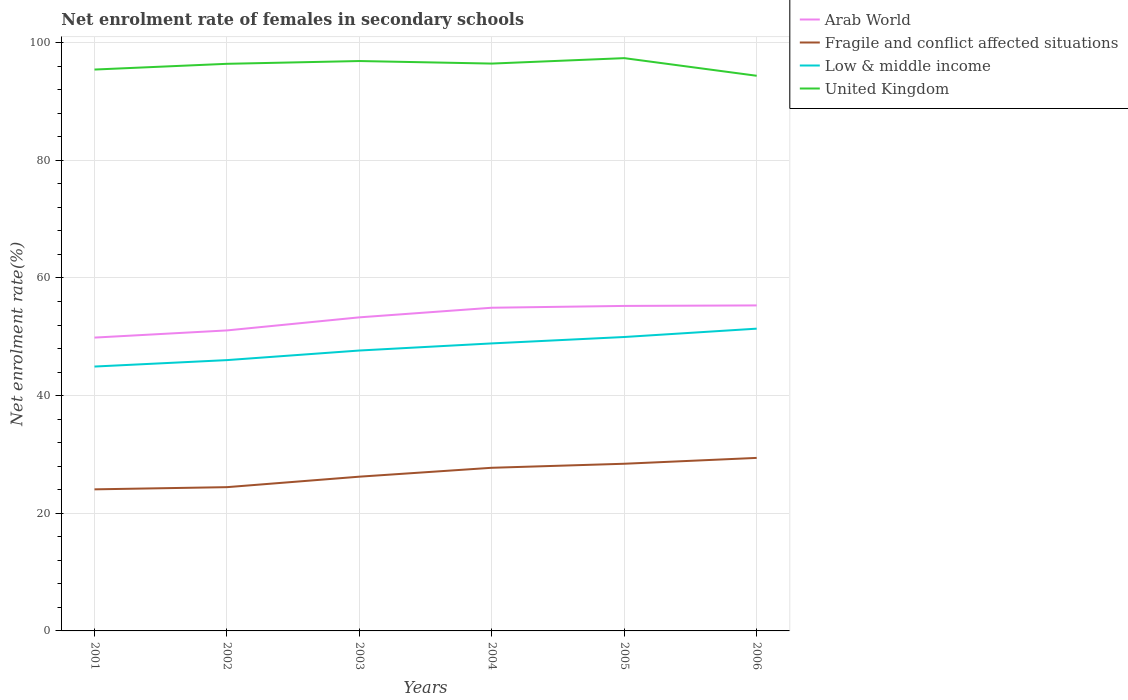How many different coloured lines are there?
Your answer should be very brief. 4. Does the line corresponding to Fragile and conflict affected situations intersect with the line corresponding to Low & middle income?
Offer a terse response. No. Is the number of lines equal to the number of legend labels?
Ensure brevity in your answer.  Yes. Across all years, what is the maximum net enrolment rate of females in secondary schools in Fragile and conflict affected situations?
Your response must be concise. 24.07. What is the total net enrolment rate of females in secondary schools in United Kingdom in the graph?
Make the answer very short. 2.51. What is the difference between the highest and the second highest net enrolment rate of females in secondary schools in Fragile and conflict affected situations?
Keep it short and to the point. 5.35. Is the net enrolment rate of females in secondary schools in Low & middle income strictly greater than the net enrolment rate of females in secondary schools in United Kingdom over the years?
Provide a succinct answer. Yes. How many lines are there?
Your answer should be compact. 4. Are the values on the major ticks of Y-axis written in scientific E-notation?
Ensure brevity in your answer.  No. Does the graph contain any zero values?
Ensure brevity in your answer.  No. Where does the legend appear in the graph?
Offer a very short reply. Top right. How are the legend labels stacked?
Your answer should be compact. Vertical. What is the title of the graph?
Provide a succinct answer. Net enrolment rate of females in secondary schools. What is the label or title of the X-axis?
Ensure brevity in your answer.  Years. What is the label or title of the Y-axis?
Give a very brief answer. Net enrolment rate(%). What is the Net enrolment rate(%) of Arab World in 2001?
Provide a succinct answer. 49.86. What is the Net enrolment rate(%) of Fragile and conflict affected situations in 2001?
Your response must be concise. 24.07. What is the Net enrolment rate(%) of Low & middle income in 2001?
Your answer should be compact. 44.94. What is the Net enrolment rate(%) in United Kingdom in 2001?
Make the answer very short. 95.43. What is the Net enrolment rate(%) in Arab World in 2002?
Provide a short and direct response. 51.08. What is the Net enrolment rate(%) of Fragile and conflict affected situations in 2002?
Provide a short and direct response. 24.44. What is the Net enrolment rate(%) in Low & middle income in 2002?
Provide a short and direct response. 46.04. What is the Net enrolment rate(%) of United Kingdom in 2002?
Make the answer very short. 96.4. What is the Net enrolment rate(%) in Arab World in 2003?
Make the answer very short. 53.31. What is the Net enrolment rate(%) in Fragile and conflict affected situations in 2003?
Keep it short and to the point. 26.22. What is the Net enrolment rate(%) of Low & middle income in 2003?
Make the answer very short. 47.67. What is the Net enrolment rate(%) of United Kingdom in 2003?
Provide a succinct answer. 96.88. What is the Net enrolment rate(%) in Arab World in 2004?
Provide a short and direct response. 54.94. What is the Net enrolment rate(%) in Fragile and conflict affected situations in 2004?
Make the answer very short. 27.73. What is the Net enrolment rate(%) of Low & middle income in 2004?
Keep it short and to the point. 48.88. What is the Net enrolment rate(%) of United Kingdom in 2004?
Keep it short and to the point. 96.44. What is the Net enrolment rate(%) of Arab World in 2005?
Provide a short and direct response. 55.25. What is the Net enrolment rate(%) in Fragile and conflict affected situations in 2005?
Keep it short and to the point. 28.42. What is the Net enrolment rate(%) in Low & middle income in 2005?
Your answer should be very brief. 49.96. What is the Net enrolment rate(%) of United Kingdom in 2005?
Ensure brevity in your answer.  97.37. What is the Net enrolment rate(%) in Arab World in 2006?
Offer a very short reply. 55.33. What is the Net enrolment rate(%) of Fragile and conflict affected situations in 2006?
Make the answer very short. 29.41. What is the Net enrolment rate(%) of Low & middle income in 2006?
Provide a short and direct response. 51.38. What is the Net enrolment rate(%) in United Kingdom in 2006?
Offer a terse response. 94.37. Across all years, what is the maximum Net enrolment rate(%) of Arab World?
Make the answer very short. 55.33. Across all years, what is the maximum Net enrolment rate(%) of Fragile and conflict affected situations?
Provide a short and direct response. 29.41. Across all years, what is the maximum Net enrolment rate(%) in Low & middle income?
Your answer should be compact. 51.38. Across all years, what is the maximum Net enrolment rate(%) in United Kingdom?
Your response must be concise. 97.37. Across all years, what is the minimum Net enrolment rate(%) of Arab World?
Your answer should be very brief. 49.86. Across all years, what is the minimum Net enrolment rate(%) in Fragile and conflict affected situations?
Keep it short and to the point. 24.07. Across all years, what is the minimum Net enrolment rate(%) of Low & middle income?
Offer a terse response. 44.94. Across all years, what is the minimum Net enrolment rate(%) of United Kingdom?
Ensure brevity in your answer.  94.37. What is the total Net enrolment rate(%) of Arab World in the graph?
Offer a very short reply. 319.77. What is the total Net enrolment rate(%) in Fragile and conflict affected situations in the graph?
Offer a very short reply. 160.29. What is the total Net enrolment rate(%) in Low & middle income in the graph?
Provide a succinct answer. 288.87. What is the total Net enrolment rate(%) of United Kingdom in the graph?
Give a very brief answer. 576.9. What is the difference between the Net enrolment rate(%) in Arab World in 2001 and that in 2002?
Give a very brief answer. -1.22. What is the difference between the Net enrolment rate(%) of Fragile and conflict affected situations in 2001 and that in 2002?
Your response must be concise. -0.37. What is the difference between the Net enrolment rate(%) in Low & middle income in 2001 and that in 2002?
Make the answer very short. -1.09. What is the difference between the Net enrolment rate(%) of United Kingdom in 2001 and that in 2002?
Your answer should be very brief. -0.97. What is the difference between the Net enrolment rate(%) of Arab World in 2001 and that in 2003?
Keep it short and to the point. -3.44. What is the difference between the Net enrolment rate(%) in Fragile and conflict affected situations in 2001 and that in 2003?
Offer a terse response. -2.15. What is the difference between the Net enrolment rate(%) in Low & middle income in 2001 and that in 2003?
Make the answer very short. -2.72. What is the difference between the Net enrolment rate(%) in United Kingdom in 2001 and that in 2003?
Provide a succinct answer. -1.45. What is the difference between the Net enrolment rate(%) of Arab World in 2001 and that in 2004?
Your response must be concise. -5.08. What is the difference between the Net enrolment rate(%) in Fragile and conflict affected situations in 2001 and that in 2004?
Your answer should be very brief. -3.67. What is the difference between the Net enrolment rate(%) of Low & middle income in 2001 and that in 2004?
Provide a short and direct response. -3.93. What is the difference between the Net enrolment rate(%) of United Kingdom in 2001 and that in 2004?
Keep it short and to the point. -1.01. What is the difference between the Net enrolment rate(%) of Arab World in 2001 and that in 2005?
Give a very brief answer. -5.38. What is the difference between the Net enrolment rate(%) in Fragile and conflict affected situations in 2001 and that in 2005?
Your answer should be very brief. -4.35. What is the difference between the Net enrolment rate(%) in Low & middle income in 2001 and that in 2005?
Keep it short and to the point. -5.02. What is the difference between the Net enrolment rate(%) in United Kingdom in 2001 and that in 2005?
Keep it short and to the point. -1.94. What is the difference between the Net enrolment rate(%) in Arab World in 2001 and that in 2006?
Keep it short and to the point. -5.47. What is the difference between the Net enrolment rate(%) of Fragile and conflict affected situations in 2001 and that in 2006?
Give a very brief answer. -5.35. What is the difference between the Net enrolment rate(%) in Low & middle income in 2001 and that in 2006?
Offer a terse response. -6.44. What is the difference between the Net enrolment rate(%) of United Kingdom in 2001 and that in 2006?
Provide a short and direct response. 1.06. What is the difference between the Net enrolment rate(%) in Arab World in 2002 and that in 2003?
Your answer should be very brief. -2.22. What is the difference between the Net enrolment rate(%) in Fragile and conflict affected situations in 2002 and that in 2003?
Keep it short and to the point. -1.78. What is the difference between the Net enrolment rate(%) of Low & middle income in 2002 and that in 2003?
Make the answer very short. -1.63. What is the difference between the Net enrolment rate(%) of United Kingdom in 2002 and that in 2003?
Keep it short and to the point. -0.47. What is the difference between the Net enrolment rate(%) of Arab World in 2002 and that in 2004?
Ensure brevity in your answer.  -3.86. What is the difference between the Net enrolment rate(%) of Fragile and conflict affected situations in 2002 and that in 2004?
Your answer should be compact. -3.3. What is the difference between the Net enrolment rate(%) in Low & middle income in 2002 and that in 2004?
Give a very brief answer. -2.84. What is the difference between the Net enrolment rate(%) of United Kingdom in 2002 and that in 2004?
Your response must be concise. -0.04. What is the difference between the Net enrolment rate(%) of Arab World in 2002 and that in 2005?
Offer a very short reply. -4.16. What is the difference between the Net enrolment rate(%) of Fragile and conflict affected situations in 2002 and that in 2005?
Your answer should be compact. -3.98. What is the difference between the Net enrolment rate(%) in Low & middle income in 2002 and that in 2005?
Your answer should be very brief. -3.93. What is the difference between the Net enrolment rate(%) in United Kingdom in 2002 and that in 2005?
Your answer should be compact. -0.97. What is the difference between the Net enrolment rate(%) in Arab World in 2002 and that in 2006?
Your response must be concise. -4.25. What is the difference between the Net enrolment rate(%) of Fragile and conflict affected situations in 2002 and that in 2006?
Make the answer very short. -4.97. What is the difference between the Net enrolment rate(%) in Low & middle income in 2002 and that in 2006?
Ensure brevity in your answer.  -5.35. What is the difference between the Net enrolment rate(%) in United Kingdom in 2002 and that in 2006?
Provide a succinct answer. 2.03. What is the difference between the Net enrolment rate(%) in Arab World in 2003 and that in 2004?
Your response must be concise. -1.63. What is the difference between the Net enrolment rate(%) of Fragile and conflict affected situations in 2003 and that in 2004?
Provide a short and direct response. -1.51. What is the difference between the Net enrolment rate(%) of Low & middle income in 2003 and that in 2004?
Your answer should be compact. -1.21. What is the difference between the Net enrolment rate(%) in United Kingdom in 2003 and that in 2004?
Provide a succinct answer. 0.43. What is the difference between the Net enrolment rate(%) in Arab World in 2003 and that in 2005?
Provide a short and direct response. -1.94. What is the difference between the Net enrolment rate(%) of Fragile and conflict affected situations in 2003 and that in 2005?
Keep it short and to the point. -2.2. What is the difference between the Net enrolment rate(%) in Low & middle income in 2003 and that in 2005?
Provide a succinct answer. -2.3. What is the difference between the Net enrolment rate(%) of United Kingdom in 2003 and that in 2005?
Give a very brief answer. -0.49. What is the difference between the Net enrolment rate(%) of Arab World in 2003 and that in 2006?
Your answer should be compact. -2.03. What is the difference between the Net enrolment rate(%) of Fragile and conflict affected situations in 2003 and that in 2006?
Provide a succinct answer. -3.19. What is the difference between the Net enrolment rate(%) of Low & middle income in 2003 and that in 2006?
Your answer should be very brief. -3.72. What is the difference between the Net enrolment rate(%) in United Kingdom in 2003 and that in 2006?
Your response must be concise. 2.51. What is the difference between the Net enrolment rate(%) in Arab World in 2004 and that in 2005?
Offer a terse response. -0.31. What is the difference between the Net enrolment rate(%) of Fragile and conflict affected situations in 2004 and that in 2005?
Ensure brevity in your answer.  -0.68. What is the difference between the Net enrolment rate(%) in Low & middle income in 2004 and that in 2005?
Keep it short and to the point. -1.09. What is the difference between the Net enrolment rate(%) in United Kingdom in 2004 and that in 2005?
Ensure brevity in your answer.  -0.93. What is the difference between the Net enrolment rate(%) of Arab World in 2004 and that in 2006?
Your answer should be compact. -0.39. What is the difference between the Net enrolment rate(%) in Fragile and conflict affected situations in 2004 and that in 2006?
Your response must be concise. -1.68. What is the difference between the Net enrolment rate(%) in Low & middle income in 2004 and that in 2006?
Keep it short and to the point. -2.51. What is the difference between the Net enrolment rate(%) in United Kingdom in 2004 and that in 2006?
Provide a short and direct response. 2.07. What is the difference between the Net enrolment rate(%) in Arab World in 2005 and that in 2006?
Ensure brevity in your answer.  -0.09. What is the difference between the Net enrolment rate(%) in Fragile and conflict affected situations in 2005 and that in 2006?
Give a very brief answer. -0.99. What is the difference between the Net enrolment rate(%) in Low & middle income in 2005 and that in 2006?
Your answer should be very brief. -1.42. What is the difference between the Net enrolment rate(%) in United Kingdom in 2005 and that in 2006?
Make the answer very short. 3. What is the difference between the Net enrolment rate(%) of Arab World in 2001 and the Net enrolment rate(%) of Fragile and conflict affected situations in 2002?
Ensure brevity in your answer.  25.43. What is the difference between the Net enrolment rate(%) of Arab World in 2001 and the Net enrolment rate(%) of Low & middle income in 2002?
Ensure brevity in your answer.  3.83. What is the difference between the Net enrolment rate(%) in Arab World in 2001 and the Net enrolment rate(%) in United Kingdom in 2002?
Ensure brevity in your answer.  -46.54. What is the difference between the Net enrolment rate(%) in Fragile and conflict affected situations in 2001 and the Net enrolment rate(%) in Low & middle income in 2002?
Your answer should be very brief. -21.97. What is the difference between the Net enrolment rate(%) of Fragile and conflict affected situations in 2001 and the Net enrolment rate(%) of United Kingdom in 2002?
Make the answer very short. -72.34. What is the difference between the Net enrolment rate(%) in Low & middle income in 2001 and the Net enrolment rate(%) in United Kingdom in 2002?
Provide a short and direct response. -51.46. What is the difference between the Net enrolment rate(%) in Arab World in 2001 and the Net enrolment rate(%) in Fragile and conflict affected situations in 2003?
Your response must be concise. 23.64. What is the difference between the Net enrolment rate(%) in Arab World in 2001 and the Net enrolment rate(%) in Low & middle income in 2003?
Provide a succinct answer. 2.2. What is the difference between the Net enrolment rate(%) of Arab World in 2001 and the Net enrolment rate(%) of United Kingdom in 2003?
Your answer should be very brief. -47.01. What is the difference between the Net enrolment rate(%) in Fragile and conflict affected situations in 2001 and the Net enrolment rate(%) in Low & middle income in 2003?
Offer a terse response. -23.6. What is the difference between the Net enrolment rate(%) in Fragile and conflict affected situations in 2001 and the Net enrolment rate(%) in United Kingdom in 2003?
Offer a terse response. -72.81. What is the difference between the Net enrolment rate(%) of Low & middle income in 2001 and the Net enrolment rate(%) of United Kingdom in 2003?
Your answer should be very brief. -51.93. What is the difference between the Net enrolment rate(%) of Arab World in 2001 and the Net enrolment rate(%) of Fragile and conflict affected situations in 2004?
Your answer should be very brief. 22.13. What is the difference between the Net enrolment rate(%) of Arab World in 2001 and the Net enrolment rate(%) of United Kingdom in 2004?
Offer a very short reply. -46.58. What is the difference between the Net enrolment rate(%) in Fragile and conflict affected situations in 2001 and the Net enrolment rate(%) in Low & middle income in 2004?
Offer a very short reply. -24.81. What is the difference between the Net enrolment rate(%) of Fragile and conflict affected situations in 2001 and the Net enrolment rate(%) of United Kingdom in 2004?
Give a very brief answer. -72.38. What is the difference between the Net enrolment rate(%) of Low & middle income in 2001 and the Net enrolment rate(%) of United Kingdom in 2004?
Your response must be concise. -51.5. What is the difference between the Net enrolment rate(%) in Arab World in 2001 and the Net enrolment rate(%) in Fragile and conflict affected situations in 2005?
Provide a succinct answer. 21.45. What is the difference between the Net enrolment rate(%) of Arab World in 2001 and the Net enrolment rate(%) of Low & middle income in 2005?
Your answer should be very brief. -0.1. What is the difference between the Net enrolment rate(%) of Arab World in 2001 and the Net enrolment rate(%) of United Kingdom in 2005?
Your answer should be compact. -47.51. What is the difference between the Net enrolment rate(%) in Fragile and conflict affected situations in 2001 and the Net enrolment rate(%) in Low & middle income in 2005?
Make the answer very short. -25.9. What is the difference between the Net enrolment rate(%) of Fragile and conflict affected situations in 2001 and the Net enrolment rate(%) of United Kingdom in 2005?
Your answer should be compact. -73.3. What is the difference between the Net enrolment rate(%) of Low & middle income in 2001 and the Net enrolment rate(%) of United Kingdom in 2005?
Your response must be concise. -52.43. What is the difference between the Net enrolment rate(%) in Arab World in 2001 and the Net enrolment rate(%) in Fragile and conflict affected situations in 2006?
Ensure brevity in your answer.  20.45. What is the difference between the Net enrolment rate(%) in Arab World in 2001 and the Net enrolment rate(%) in Low & middle income in 2006?
Offer a very short reply. -1.52. What is the difference between the Net enrolment rate(%) of Arab World in 2001 and the Net enrolment rate(%) of United Kingdom in 2006?
Provide a short and direct response. -44.51. What is the difference between the Net enrolment rate(%) of Fragile and conflict affected situations in 2001 and the Net enrolment rate(%) of Low & middle income in 2006?
Offer a very short reply. -27.32. What is the difference between the Net enrolment rate(%) of Fragile and conflict affected situations in 2001 and the Net enrolment rate(%) of United Kingdom in 2006?
Give a very brief answer. -70.3. What is the difference between the Net enrolment rate(%) in Low & middle income in 2001 and the Net enrolment rate(%) in United Kingdom in 2006?
Provide a short and direct response. -49.43. What is the difference between the Net enrolment rate(%) of Arab World in 2002 and the Net enrolment rate(%) of Fragile and conflict affected situations in 2003?
Offer a terse response. 24.86. What is the difference between the Net enrolment rate(%) in Arab World in 2002 and the Net enrolment rate(%) in Low & middle income in 2003?
Your answer should be very brief. 3.42. What is the difference between the Net enrolment rate(%) of Arab World in 2002 and the Net enrolment rate(%) of United Kingdom in 2003?
Provide a succinct answer. -45.79. What is the difference between the Net enrolment rate(%) in Fragile and conflict affected situations in 2002 and the Net enrolment rate(%) in Low & middle income in 2003?
Ensure brevity in your answer.  -23.23. What is the difference between the Net enrolment rate(%) of Fragile and conflict affected situations in 2002 and the Net enrolment rate(%) of United Kingdom in 2003?
Keep it short and to the point. -72.44. What is the difference between the Net enrolment rate(%) in Low & middle income in 2002 and the Net enrolment rate(%) in United Kingdom in 2003?
Your answer should be compact. -50.84. What is the difference between the Net enrolment rate(%) of Arab World in 2002 and the Net enrolment rate(%) of Fragile and conflict affected situations in 2004?
Provide a succinct answer. 23.35. What is the difference between the Net enrolment rate(%) in Arab World in 2002 and the Net enrolment rate(%) in Low & middle income in 2004?
Your response must be concise. 2.21. What is the difference between the Net enrolment rate(%) of Arab World in 2002 and the Net enrolment rate(%) of United Kingdom in 2004?
Offer a very short reply. -45.36. What is the difference between the Net enrolment rate(%) in Fragile and conflict affected situations in 2002 and the Net enrolment rate(%) in Low & middle income in 2004?
Your response must be concise. -24.44. What is the difference between the Net enrolment rate(%) in Fragile and conflict affected situations in 2002 and the Net enrolment rate(%) in United Kingdom in 2004?
Provide a succinct answer. -72.01. What is the difference between the Net enrolment rate(%) in Low & middle income in 2002 and the Net enrolment rate(%) in United Kingdom in 2004?
Ensure brevity in your answer.  -50.41. What is the difference between the Net enrolment rate(%) in Arab World in 2002 and the Net enrolment rate(%) in Fragile and conflict affected situations in 2005?
Offer a very short reply. 22.67. What is the difference between the Net enrolment rate(%) in Arab World in 2002 and the Net enrolment rate(%) in Low & middle income in 2005?
Provide a short and direct response. 1.12. What is the difference between the Net enrolment rate(%) in Arab World in 2002 and the Net enrolment rate(%) in United Kingdom in 2005?
Make the answer very short. -46.29. What is the difference between the Net enrolment rate(%) of Fragile and conflict affected situations in 2002 and the Net enrolment rate(%) of Low & middle income in 2005?
Your response must be concise. -25.53. What is the difference between the Net enrolment rate(%) in Fragile and conflict affected situations in 2002 and the Net enrolment rate(%) in United Kingdom in 2005?
Give a very brief answer. -72.93. What is the difference between the Net enrolment rate(%) of Low & middle income in 2002 and the Net enrolment rate(%) of United Kingdom in 2005?
Your response must be concise. -51.33. What is the difference between the Net enrolment rate(%) of Arab World in 2002 and the Net enrolment rate(%) of Fragile and conflict affected situations in 2006?
Offer a terse response. 21.67. What is the difference between the Net enrolment rate(%) in Arab World in 2002 and the Net enrolment rate(%) in Low & middle income in 2006?
Offer a very short reply. -0.3. What is the difference between the Net enrolment rate(%) in Arab World in 2002 and the Net enrolment rate(%) in United Kingdom in 2006?
Your response must be concise. -43.29. What is the difference between the Net enrolment rate(%) of Fragile and conflict affected situations in 2002 and the Net enrolment rate(%) of Low & middle income in 2006?
Make the answer very short. -26.94. What is the difference between the Net enrolment rate(%) of Fragile and conflict affected situations in 2002 and the Net enrolment rate(%) of United Kingdom in 2006?
Your response must be concise. -69.93. What is the difference between the Net enrolment rate(%) of Low & middle income in 2002 and the Net enrolment rate(%) of United Kingdom in 2006?
Offer a very short reply. -48.34. What is the difference between the Net enrolment rate(%) of Arab World in 2003 and the Net enrolment rate(%) of Fragile and conflict affected situations in 2004?
Provide a succinct answer. 25.57. What is the difference between the Net enrolment rate(%) in Arab World in 2003 and the Net enrolment rate(%) in Low & middle income in 2004?
Provide a short and direct response. 4.43. What is the difference between the Net enrolment rate(%) of Arab World in 2003 and the Net enrolment rate(%) of United Kingdom in 2004?
Offer a very short reply. -43.14. What is the difference between the Net enrolment rate(%) of Fragile and conflict affected situations in 2003 and the Net enrolment rate(%) of Low & middle income in 2004?
Provide a succinct answer. -22.66. What is the difference between the Net enrolment rate(%) of Fragile and conflict affected situations in 2003 and the Net enrolment rate(%) of United Kingdom in 2004?
Provide a short and direct response. -70.22. What is the difference between the Net enrolment rate(%) of Low & middle income in 2003 and the Net enrolment rate(%) of United Kingdom in 2004?
Offer a terse response. -48.78. What is the difference between the Net enrolment rate(%) in Arab World in 2003 and the Net enrolment rate(%) in Fragile and conflict affected situations in 2005?
Offer a very short reply. 24.89. What is the difference between the Net enrolment rate(%) in Arab World in 2003 and the Net enrolment rate(%) in Low & middle income in 2005?
Provide a short and direct response. 3.34. What is the difference between the Net enrolment rate(%) of Arab World in 2003 and the Net enrolment rate(%) of United Kingdom in 2005?
Your answer should be very brief. -44.06. What is the difference between the Net enrolment rate(%) of Fragile and conflict affected situations in 2003 and the Net enrolment rate(%) of Low & middle income in 2005?
Provide a short and direct response. -23.74. What is the difference between the Net enrolment rate(%) of Fragile and conflict affected situations in 2003 and the Net enrolment rate(%) of United Kingdom in 2005?
Your answer should be compact. -71.15. What is the difference between the Net enrolment rate(%) in Low & middle income in 2003 and the Net enrolment rate(%) in United Kingdom in 2005?
Provide a succinct answer. -49.7. What is the difference between the Net enrolment rate(%) of Arab World in 2003 and the Net enrolment rate(%) of Fragile and conflict affected situations in 2006?
Your answer should be compact. 23.89. What is the difference between the Net enrolment rate(%) of Arab World in 2003 and the Net enrolment rate(%) of Low & middle income in 2006?
Ensure brevity in your answer.  1.92. What is the difference between the Net enrolment rate(%) of Arab World in 2003 and the Net enrolment rate(%) of United Kingdom in 2006?
Make the answer very short. -41.07. What is the difference between the Net enrolment rate(%) in Fragile and conflict affected situations in 2003 and the Net enrolment rate(%) in Low & middle income in 2006?
Offer a terse response. -25.16. What is the difference between the Net enrolment rate(%) in Fragile and conflict affected situations in 2003 and the Net enrolment rate(%) in United Kingdom in 2006?
Provide a short and direct response. -68.15. What is the difference between the Net enrolment rate(%) of Low & middle income in 2003 and the Net enrolment rate(%) of United Kingdom in 2006?
Provide a succinct answer. -46.71. What is the difference between the Net enrolment rate(%) of Arab World in 2004 and the Net enrolment rate(%) of Fragile and conflict affected situations in 2005?
Give a very brief answer. 26.52. What is the difference between the Net enrolment rate(%) in Arab World in 2004 and the Net enrolment rate(%) in Low & middle income in 2005?
Your answer should be compact. 4.97. What is the difference between the Net enrolment rate(%) in Arab World in 2004 and the Net enrolment rate(%) in United Kingdom in 2005?
Your answer should be compact. -42.43. What is the difference between the Net enrolment rate(%) of Fragile and conflict affected situations in 2004 and the Net enrolment rate(%) of Low & middle income in 2005?
Your response must be concise. -22.23. What is the difference between the Net enrolment rate(%) in Fragile and conflict affected situations in 2004 and the Net enrolment rate(%) in United Kingdom in 2005?
Provide a short and direct response. -69.64. What is the difference between the Net enrolment rate(%) of Low & middle income in 2004 and the Net enrolment rate(%) of United Kingdom in 2005?
Offer a terse response. -48.49. What is the difference between the Net enrolment rate(%) of Arab World in 2004 and the Net enrolment rate(%) of Fragile and conflict affected situations in 2006?
Provide a short and direct response. 25.53. What is the difference between the Net enrolment rate(%) in Arab World in 2004 and the Net enrolment rate(%) in Low & middle income in 2006?
Your response must be concise. 3.56. What is the difference between the Net enrolment rate(%) in Arab World in 2004 and the Net enrolment rate(%) in United Kingdom in 2006?
Your response must be concise. -39.43. What is the difference between the Net enrolment rate(%) in Fragile and conflict affected situations in 2004 and the Net enrolment rate(%) in Low & middle income in 2006?
Keep it short and to the point. -23.65. What is the difference between the Net enrolment rate(%) of Fragile and conflict affected situations in 2004 and the Net enrolment rate(%) of United Kingdom in 2006?
Your answer should be very brief. -66.64. What is the difference between the Net enrolment rate(%) in Low & middle income in 2004 and the Net enrolment rate(%) in United Kingdom in 2006?
Keep it short and to the point. -45.5. What is the difference between the Net enrolment rate(%) in Arab World in 2005 and the Net enrolment rate(%) in Fragile and conflict affected situations in 2006?
Your answer should be very brief. 25.83. What is the difference between the Net enrolment rate(%) in Arab World in 2005 and the Net enrolment rate(%) in Low & middle income in 2006?
Provide a succinct answer. 3.86. What is the difference between the Net enrolment rate(%) of Arab World in 2005 and the Net enrolment rate(%) of United Kingdom in 2006?
Keep it short and to the point. -39.13. What is the difference between the Net enrolment rate(%) in Fragile and conflict affected situations in 2005 and the Net enrolment rate(%) in Low & middle income in 2006?
Your response must be concise. -22.96. What is the difference between the Net enrolment rate(%) of Fragile and conflict affected situations in 2005 and the Net enrolment rate(%) of United Kingdom in 2006?
Offer a very short reply. -65.95. What is the difference between the Net enrolment rate(%) of Low & middle income in 2005 and the Net enrolment rate(%) of United Kingdom in 2006?
Keep it short and to the point. -44.41. What is the average Net enrolment rate(%) of Arab World per year?
Provide a succinct answer. 53.3. What is the average Net enrolment rate(%) of Fragile and conflict affected situations per year?
Give a very brief answer. 26.72. What is the average Net enrolment rate(%) of Low & middle income per year?
Offer a terse response. 48.14. What is the average Net enrolment rate(%) in United Kingdom per year?
Ensure brevity in your answer.  96.15. In the year 2001, what is the difference between the Net enrolment rate(%) of Arab World and Net enrolment rate(%) of Fragile and conflict affected situations?
Provide a short and direct response. 25.8. In the year 2001, what is the difference between the Net enrolment rate(%) of Arab World and Net enrolment rate(%) of Low & middle income?
Your answer should be compact. 4.92. In the year 2001, what is the difference between the Net enrolment rate(%) in Arab World and Net enrolment rate(%) in United Kingdom?
Offer a very short reply. -45.57. In the year 2001, what is the difference between the Net enrolment rate(%) of Fragile and conflict affected situations and Net enrolment rate(%) of Low & middle income?
Ensure brevity in your answer.  -20.88. In the year 2001, what is the difference between the Net enrolment rate(%) of Fragile and conflict affected situations and Net enrolment rate(%) of United Kingdom?
Your answer should be compact. -71.36. In the year 2001, what is the difference between the Net enrolment rate(%) of Low & middle income and Net enrolment rate(%) of United Kingdom?
Your response must be concise. -50.49. In the year 2002, what is the difference between the Net enrolment rate(%) of Arab World and Net enrolment rate(%) of Fragile and conflict affected situations?
Offer a very short reply. 26.65. In the year 2002, what is the difference between the Net enrolment rate(%) of Arab World and Net enrolment rate(%) of Low & middle income?
Keep it short and to the point. 5.05. In the year 2002, what is the difference between the Net enrolment rate(%) of Arab World and Net enrolment rate(%) of United Kingdom?
Your response must be concise. -45.32. In the year 2002, what is the difference between the Net enrolment rate(%) of Fragile and conflict affected situations and Net enrolment rate(%) of Low & middle income?
Provide a succinct answer. -21.6. In the year 2002, what is the difference between the Net enrolment rate(%) in Fragile and conflict affected situations and Net enrolment rate(%) in United Kingdom?
Your response must be concise. -71.97. In the year 2002, what is the difference between the Net enrolment rate(%) of Low & middle income and Net enrolment rate(%) of United Kingdom?
Provide a short and direct response. -50.37. In the year 2003, what is the difference between the Net enrolment rate(%) in Arab World and Net enrolment rate(%) in Fragile and conflict affected situations?
Offer a terse response. 27.08. In the year 2003, what is the difference between the Net enrolment rate(%) in Arab World and Net enrolment rate(%) in Low & middle income?
Offer a terse response. 5.64. In the year 2003, what is the difference between the Net enrolment rate(%) of Arab World and Net enrolment rate(%) of United Kingdom?
Give a very brief answer. -43.57. In the year 2003, what is the difference between the Net enrolment rate(%) in Fragile and conflict affected situations and Net enrolment rate(%) in Low & middle income?
Provide a succinct answer. -21.45. In the year 2003, what is the difference between the Net enrolment rate(%) of Fragile and conflict affected situations and Net enrolment rate(%) of United Kingdom?
Provide a succinct answer. -70.66. In the year 2003, what is the difference between the Net enrolment rate(%) in Low & middle income and Net enrolment rate(%) in United Kingdom?
Give a very brief answer. -49.21. In the year 2004, what is the difference between the Net enrolment rate(%) of Arab World and Net enrolment rate(%) of Fragile and conflict affected situations?
Provide a succinct answer. 27.21. In the year 2004, what is the difference between the Net enrolment rate(%) in Arab World and Net enrolment rate(%) in Low & middle income?
Make the answer very short. 6.06. In the year 2004, what is the difference between the Net enrolment rate(%) of Arab World and Net enrolment rate(%) of United Kingdom?
Give a very brief answer. -41.51. In the year 2004, what is the difference between the Net enrolment rate(%) of Fragile and conflict affected situations and Net enrolment rate(%) of Low & middle income?
Keep it short and to the point. -21.14. In the year 2004, what is the difference between the Net enrolment rate(%) in Fragile and conflict affected situations and Net enrolment rate(%) in United Kingdom?
Give a very brief answer. -68.71. In the year 2004, what is the difference between the Net enrolment rate(%) in Low & middle income and Net enrolment rate(%) in United Kingdom?
Make the answer very short. -47.57. In the year 2005, what is the difference between the Net enrolment rate(%) in Arab World and Net enrolment rate(%) in Fragile and conflict affected situations?
Make the answer very short. 26.83. In the year 2005, what is the difference between the Net enrolment rate(%) in Arab World and Net enrolment rate(%) in Low & middle income?
Offer a very short reply. 5.28. In the year 2005, what is the difference between the Net enrolment rate(%) in Arab World and Net enrolment rate(%) in United Kingdom?
Keep it short and to the point. -42.12. In the year 2005, what is the difference between the Net enrolment rate(%) of Fragile and conflict affected situations and Net enrolment rate(%) of Low & middle income?
Give a very brief answer. -21.55. In the year 2005, what is the difference between the Net enrolment rate(%) of Fragile and conflict affected situations and Net enrolment rate(%) of United Kingdom?
Your response must be concise. -68.95. In the year 2005, what is the difference between the Net enrolment rate(%) in Low & middle income and Net enrolment rate(%) in United Kingdom?
Your answer should be compact. -47.4. In the year 2006, what is the difference between the Net enrolment rate(%) of Arab World and Net enrolment rate(%) of Fragile and conflict affected situations?
Provide a succinct answer. 25.92. In the year 2006, what is the difference between the Net enrolment rate(%) in Arab World and Net enrolment rate(%) in Low & middle income?
Your response must be concise. 3.95. In the year 2006, what is the difference between the Net enrolment rate(%) of Arab World and Net enrolment rate(%) of United Kingdom?
Ensure brevity in your answer.  -39.04. In the year 2006, what is the difference between the Net enrolment rate(%) in Fragile and conflict affected situations and Net enrolment rate(%) in Low & middle income?
Provide a succinct answer. -21.97. In the year 2006, what is the difference between the Net enrolment rate(%) of Fragile and conflict affected situations and Net enrolment rate(%) of United Kingdom?
Your response must be concise. -64.96. In the year 2006, what is the difference between the Net enrolment rate(%) in Low & middle income and Net enrolment rate(%) in United Kingdom?
Keep it short and to the point. -42.99. What is the ratio of the Net enrolment rate(%) of Arab World in 2001 to that in 2002?
Give a very brief answer. 0.98. What is the ratio of the Net enrolment rate(%) of Fragile and conflict affected situations in 2001 to that in 2002?
Give a very brief answer. 0.98. What is the ratio of the Net enrolment rate(%) in Low & middle income in 2001 to that in 2002?
Offer a terse response. 0.98. What is the ratio of the Net enrolment rate(%) of United Kingdom in 2001 to that in 2002?
Make the answer very short. 0.99. What is the ratio of the Net enrolment rate(%) of Arab World in 2001 to that in 2003?
Offer a terse response. 0.94. What is the ratio of the Net enrolment rate(%) in Fragile and conflict affected situations in 2001 to that in 2003?
Your answer should be very brief. 0.92. What is the ratio of the Net enrolment rate(%) of Low & middle income in 2001 to that in 2003?
Your response must be concise. 0.94. What is the ratio of the Net enrolment rate(%) of United Kingdom in 2001 to that in 2003?
Give a very brief answer. 0.99. What is the ratio of the Net enrolment rate(%) of Arab World in 2001 to that in 2004?
Your answer should be very brief. 0.91. What is the ratio of the Net enrolment rate(%) of Fragile and conflict affected situations in 2001 to that in 2004?
Ensure brevity in your answer.  0.87. What is the ratio of the Net enrolment rate(%) of Low & middle income in 2001 to that in 2004?
Your answer should be compact. 0.92. What is the ratio of the Net enrolment rate(%) in United Kingdom in 2001 to that in 2004?
Your answer should be very brief. 0.99. What is the ratio of the Net enrolment rate(%) in Arab World in 2001 to that in 2005?
Keep it short and to the point. 0.9. What is the ratio of the Net enrolment rate(%) of Fragile and conflict affected situations in 2001 to that in 2005?
Give a very brief answer. 0.85. What is the ratio of the Net enrolment rate(%) of Low & middle income in 2001 to that in 2005?
Your answer should be compact. 0.9. What is the ratio of the Net enrolment rate(%) in United Kingdom in 2001 to that in 2005?
Your answer should be very brief. 0.98. What is the ratio of the Net enrolment rate(%) in Arab World in 2001 to that in 2006?
Your response must be concise. 0.9. What is the ratio of the Net enrolment rate(%) of Fragile and conflict affected situations in 2001 to that in 2006?
Offer a terse response. 0.82. What is the ratio of the Net enrolment rate(%) in Low & middle income in 2001 to that in 2006?
Make the answer very short. 0.87. What is the ratio of the Net enrolment rate(%) in United Kingdom in 2001 to that in 2006?
Ensure brevity in your answer.  1.01. What is the ratio of the Net enrolment rate(%) of Fragile and conflict affected situations in 2002 to that in 2003?
Keep it short and to the point. 0.93. What is the ratio of the Net enrolment rate(%) of Low & middle income in 2002 to that in 2003?
Provide a succinct answer. 0.97. What is the ratio of the Net enrolment rate(%) of Arab World in 2002 to that in 2004?
Your response must be concise. 0.93. What is the ratio of the Net enrolment rate(%) in Fragile and conflict affected situations in 2002 to that in 2004?
Offer a very short reply. 0.88. What is the ratio of the Net enrolment rate(%) of Low & middle income in 2002 to that in 2004?
Your answer should be very brief. 0.94. What is the ratio of the Net enrolment rate(%) of United Kingdom in 2002 to that in 2004?
Provide a short and direct response. 1. What is the ratio of the Net enrolment rate(%) of Arab World in 2002 to that in 2005?
Provide a succinct answer. 0.92. What is the ratio of the Net enrolment rate(%) of Fragile and conflict affected situations in 2002 to that in 2005?
Provide a succinct answer. 0.86. What is the ratio of the Net enrolment rate(%) in Low & middle income in 2002 to that in 2005?
Keep it short and to the point. 0.92. What is the ratio of the Net enrolment rate(%) of Arab World in 2002 to that in 2006?
Your answer should be very brief. 0.92. What is the ratio of the Net enrolment rate(%) in Fragile and conflict affected situations in 2002 to that in 2006?
Your response must be concise. 0.83. What is the ratio of the Net enrolment rate(%) in Low & middle income in 2002 to that in 2006?
Your answer should be compact. 0.9. What is the ratio of the Net enrolment rate(%) of United Kingdom in 2002 to that in 2006?
Offer a terse response. 1.02. What is the ratio of the Net enrolment rate(%) in Arab World in 2003 to that in 2004?
Give a very brief answer. 0.97. What is the ratio of the Net enrolment rate(%) in Fragile and conflict affected situations in 2003 to that in 2004?
Your answer should be very brief. 0.95. What is the ratio of the Net enrolment rate(%) in Low & middle income in 2003 to that in 2004?
Offer a very short reply. 0.98. What is the ratio of the Net enrolment rate(%) in United Kingdom in 2003 to that in 2004?
Your answer should be very brief. 1. What is the ratio of the Net enrolment rate(%) of Arab World in 2003 to that in 2005?
Offer a terse response. 0.96. What is the ratio of the Net enrolment rate(%) of Fragile and conflict affected situations in 2003 to that in 2005?
Give a very brief answer. 0.92. What is the ratio of the Net enrolment rate(%) in Low & middle income in 2003 to that in 2005?
Your answer should be very brief. 0.95. What is the ratio of the Net enrolment rate(%) of United Kingdom in 2003 to that in 2005?
Your response must be concise. 0.99. What is the ratio of the Net enrolment rate(%) in Arab World in 2003 to that in 2006?
Offer a very short reply. 0.96. What is the ratio of the Net enrolment rate(%) in Fragile and conflict affected situations in 2003 to that in 2006?
Offer a terse response. 0.89. What is the ratio of the Net enrolment rate(%) in Low & middle income in 2003 to that in 2006?
Your answer should be compact. 0.93. What is the ratio of the Net enrolment rate(%) of United Kingdom in 2003 to that in 2006?
Your response must be concise. 1.03. What is the ratio of the Net enrolment rate(%) in Fragile and conflict affected situations in 2004 to that in 2005?
Offer a terse response. 0.98. What is the ratio of the Net enrolment rate(%) of Low & middle income in 2004 to that in 2005?
Make the answer very short. 0.98. What is the ratio of the Net enrolment rate(%) in Arab World in 2004 to that in 2006?
Offer a very short reply. 0.99. What is the ratio of the Net enrolment rate(%) of Fragile and conflict affected situations in 2004 to that in 2006?
Your answer should be compact. 0.94. What is the ratio of the Net enrolment rate(%) in Low & middle income in 2004 to that in 2006?
Provide a succinct answer. 0.95. What is the ratio of the Net enrolment rate(%) of United Kingdom in 2004 to that in 2006?
Your answer should be compact. 1.02. What is the ratio of the Net enrolment rate(%) of Fragile and conflict affected situations in 2005 to that in 2006?
Your answer should be very brief. 0.97. What is the ratio of the Net enrolment rate(%) of Low & middle income in 2005 to that in 2006?
Provide a succinct answer. 0.97. What is the ratio of the Net enrolment rate(%) of United Kingdom in 2005 to that in 2006?
Make the answer very short. 1.03. What is the difference between the highest and the second highest Net enrolment rate(%) of Arab World?
Your response must be concise. 0.09. What is the difference between the highest and the second highest Net enrolment rate(%) in Low & middle income?
Ensure brevity in your answer.  1.42. What is the difference between the highest and the second highest Net enrolment rate(%) in United Kingdom?
Your answer should be compact. 0.49. What is the difference between the highest and the lowest Net enrolment rate(%) in Arab World?
Make the answer very short. 5.47. What is the difference between the highest and the lowest Net enrolment rate(%) of Fragile and conflict affected situations?
Provide a succinct answer. 5.35. What is the difference between the highest and the lowest Net enrolment rate(%) in Low & middle income?
Give a very brief answer. 6.44. What is the difference between the highest and the lowest Net enrolment rate(%) of United Kingdom?
Provide a short and direct response. 3. 